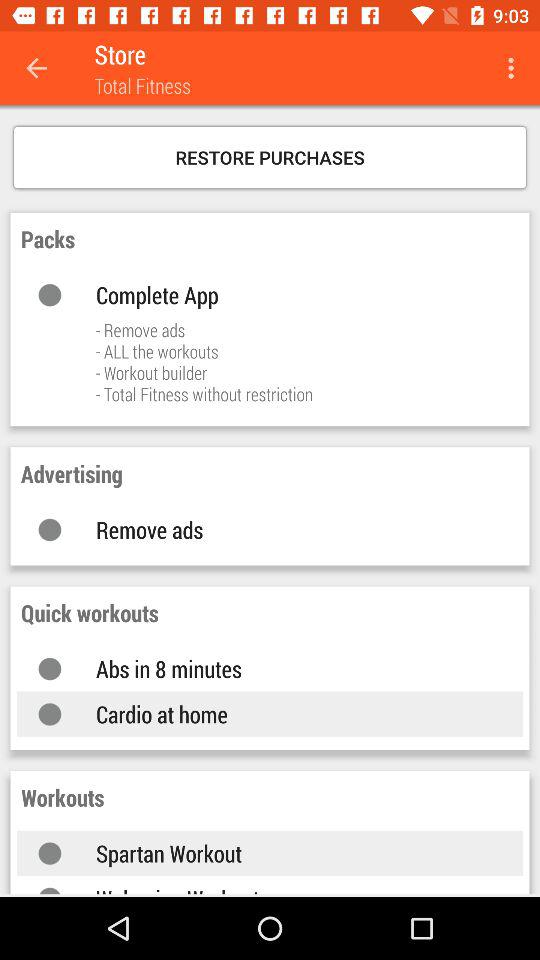What are the quick workouts? The quick workouts are "Abs in 8 minutes" and "Cardio at home". 